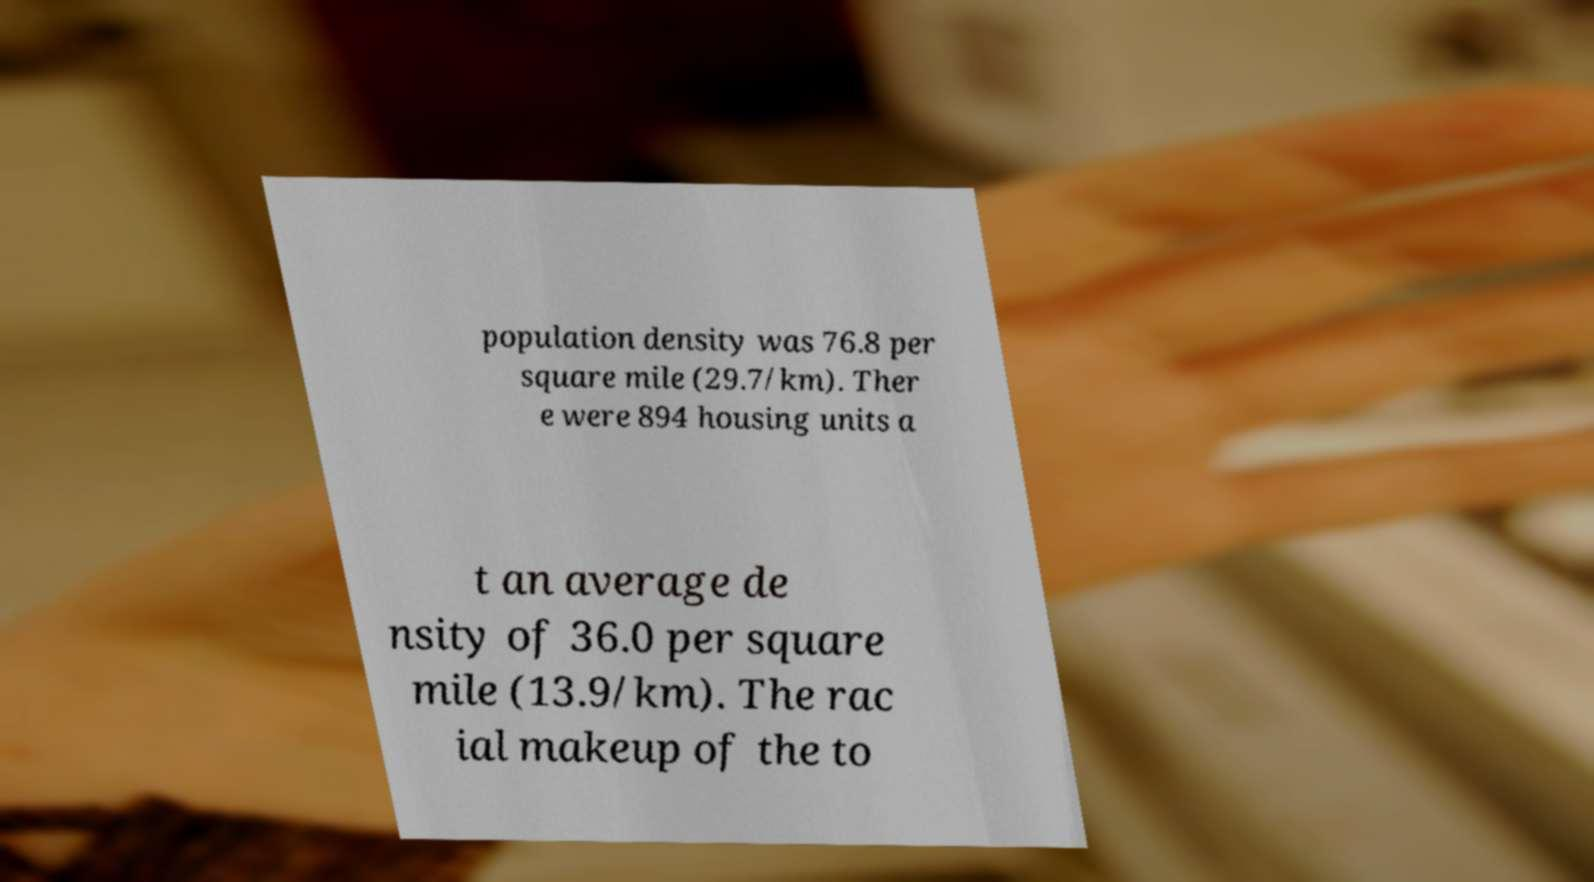Please identify and transcribe the text found in this image. population density was 76.8 per square mile (29.7/km). Ther e were 894 housing units a t an average de nsity of 36.0 per square mile (13.9/km). The rac ial makeup of the to 